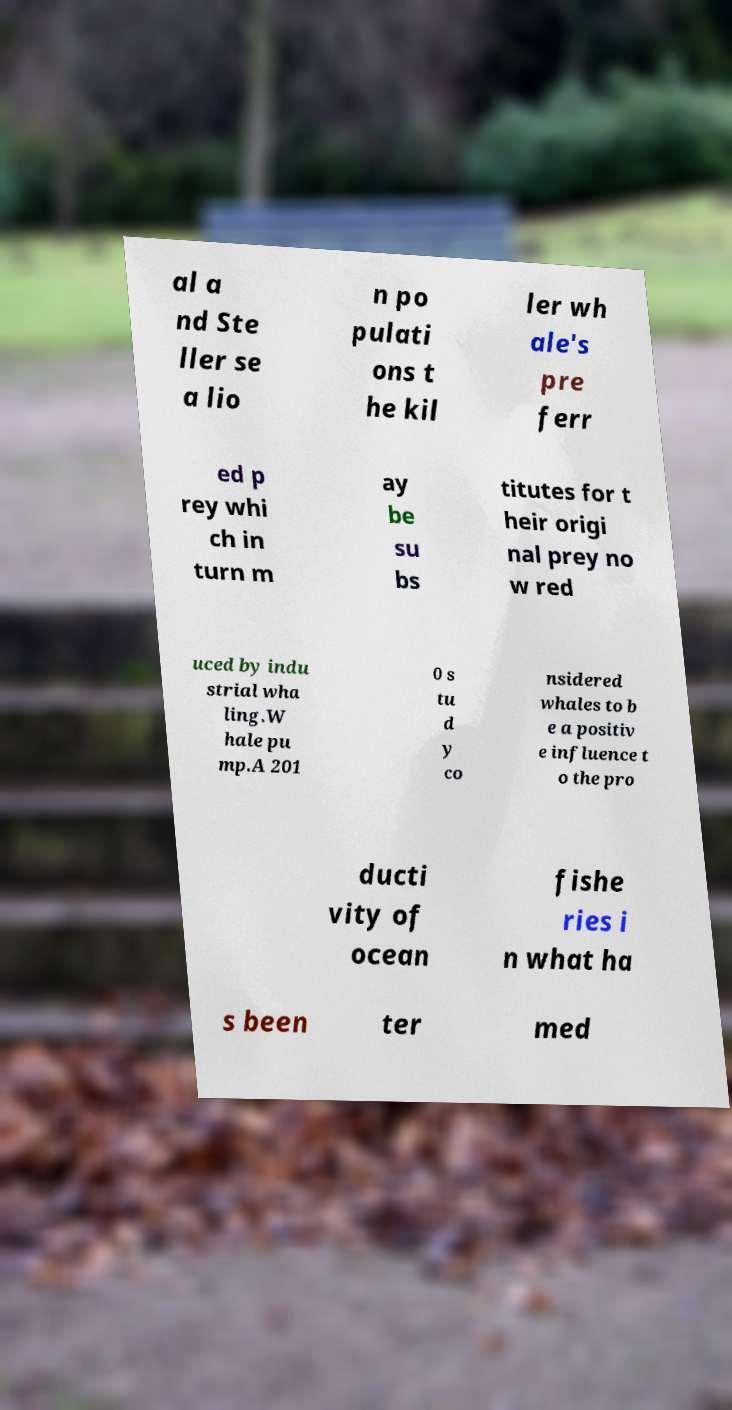I need the written content from this picture converted into text. Can you do that? al a nd Ste ller se a lio n po pulati ons t he kil ler wh ale's pre ferr ed p rey whi ch in turn m ay be su bs titutes for t heir origi nal prey no w red uced by indu strial wha ling.W hale pu mp.A 201 0 s tu d y co nsidered whales to b e a positiv e influence t o the pro ducti vity of ocean fishe ries i n what ha s been ter med 